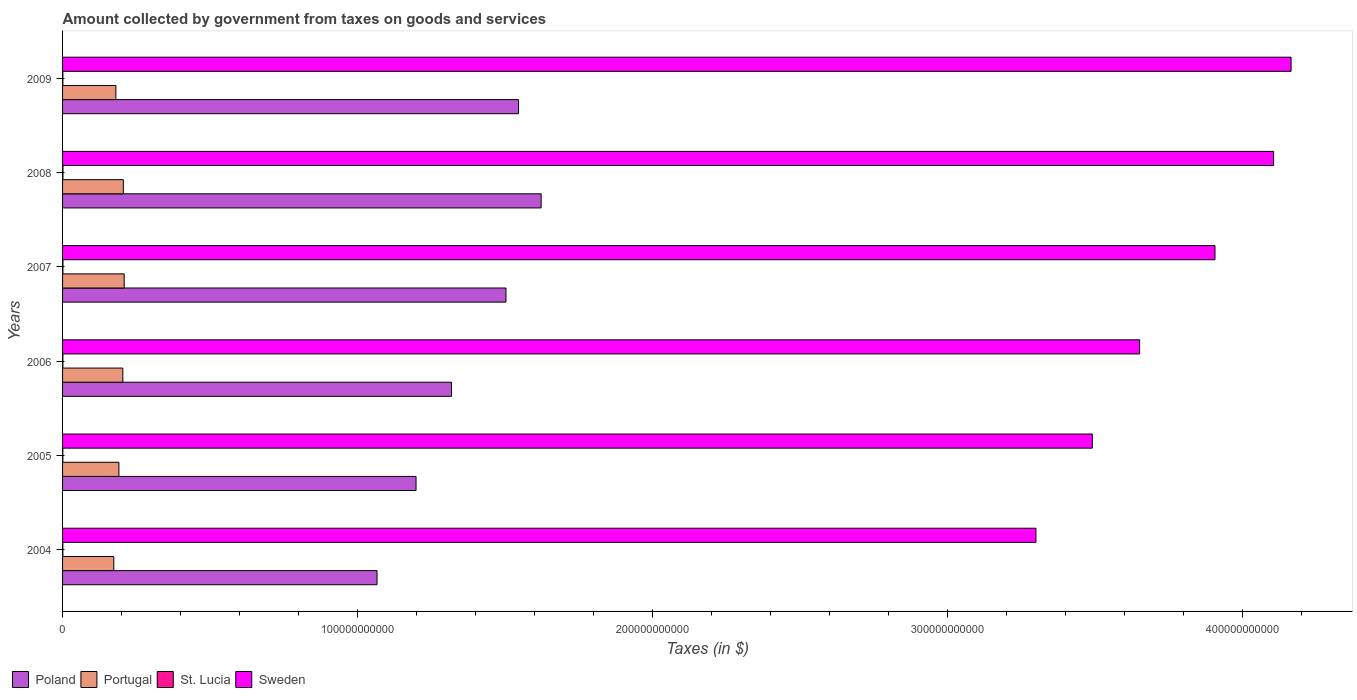How many groups of bars are there?
Make the answer very short. 6. Are the number of bars per tick equal to the number of legend labels?
Provide a succinct answer. Yes. What is the amount collected by government from taxes on goods and services in Portugal in 2006?
Offer a terse response. 2.04e+1. Across all years, what is the maximum amount collected by government from taxes on goods and services in Poland?
Provide a short and direct response. 1.62e+11. Across all years, what is the minimum amount collected by government from taxes on goods and services in Poland?
Your answer should be very brief. 1.07e+11. In which year was the amount collected by government from taxes on goods and services in Portugal maximum?
Give a very brief answer. 2007. What is the total amount collected by government from taxes on goods and services in St. Lucia in the graph?
Give a very brief answer. 6.48e+08. What is the difference between the amount collected by government from taxes on goods and services in St. Lucia in 2006 and that in 2008?
Keep it short and to the point. -2.66e+07. What is the difference between the amount collected by government from taxes on goods and services in Poland in 2004 and the amount collected by government from taxes on goods and services in Portugal in 2005?
Provide a short and direct response. 8.75e+1. What is the average amount collected by government from taxes on goods and services in St. Lucia per year?
Ensure brevity in your answer.  1.08e+08. In the year 2006, what is the difference between the amount collected by government from taxes on goods and services in Portugal and amount collected by government from taxes on goods and services in St. Lucia?
Your answer should be very brief. 2.03e+1. In how many years, is the amount collected by government from taxes on goods and services in St. Lucia greater than 260000000000 $?
Offer a very short reply. 0. What is the ratio of the amount collected by government from taxes on goods and services in Poland in 2005 to that in 2009?
Your response must be concise. 0.78. Is the amount collected by government from taxes on goods and services in St. Lucia in 2008 less than that in 2009?
Give a very brief answer. No. Is the difference between the amount collected by government from taxes on goods and services in Portugal in 2004 and 2005 greater than the difference between the amount collected by government from taxes on goods and services in St. Lucia in 2004 and 2005?
Your answer should be very brief. No. What is the difference between the highest and the second highest amount collected by government from taxes on goods and services in Sweden?
Make the answer very short. 5.91e+09. What is the difference between the highest and the lowest amount collected by government from taxes on goods and services in St. Lucia?
Your answer should be very brief. 4.27e+07. In how many years, is the amount collected by government from taxes on goods and services in St. Lucia greater than the average amount collected by government from taxes on goods and services in St. Lucia taken over all years?
Make the answer very short. 2. Is the sum of the amount collected by government from taxes on goods and services in St. Lucia in 2007 and 2008 greater than the maximum amount collected by government from taxes on goods and services in Portugal across all years?
Your answer should be very brief. No. Is it the case that in every year, the sum of the amount collected by government from taxes on goods and services in Sweden and amount collected by government from taxes on goods and services in Poland is greater than the sum of amount collected by government from taxes on goods and services in St. Lucia and amount collected by government from taxes on goods and services in Portugal?
Ensure brevity in your answer.  Yes. What is the difference between two consecutive major ticks on the X-axis?
Provide a short and direct response. 1.00e+11. Does the graph contain any zero values?
Make the answer very short. No. Where does the legend appear in the graph?
Your response must be concise. Bottom left. How are the legend labels stacked?
Ensure brevity in your answer.  Horizontal. What is the title of the graph?
Make the answer very short. Amount collected by government from taxes on goods and services. What is the label or title of the X-axis?
Offer a terse response. Taxes (in $). What is the label or title of the Y-axis?
Make the answer very short. Years. What is the Taxes (in $) of Poland in 2004?
Make the answer very short. 1.07e+11. What is the Taxes (in $) of Portugal in 2004?
Your answer should be compact. 1.74e+1. What is the Taxes (in $) of St. Lucia in 2004?
Make the answer very short. 9.33e+07. What is the Taxes (in $) in Sweden in 2004?
Make the answer very short. 3.30e+11. What is the Taxes (in $) in Poland in 2005?
Your answer should be very brief. 1.20e+11. What is the Taxes (in $) in Portugal in 2005?
Your answer should be very brief. 1.91e+1. What is the Taxes (in $) of St. Lucia in 2005?
Offer a terse response. 8.95e+07. What is the Taxes (in $) in Sweden in 2005?
Give a very brief answer. 3.49e+11. What is the Taxes (in $) of Poland in 2006?
Ensure brevity in your answer.  1.32e+11. What is the Taxes (in $) in Portugal in 2006?
Your response must be concise. 2.04e+1. What is the Taxes (in $) of St. Lucia in 2006?
Your answer should be very brief. 1.06e+08. What is the Taxes (in $) of Sweden in 2006?
Give a very brief answer. 3.65e+11. What is the Taxes (in $) of Poland in 2007?
Offer a terse response. 1.50e+11. What is the Taxes (in $) of Portugal in 2007?
Provide a short and direct response. 2.09e+1. What is the Taxes (in $) of St. Lucia in 2007?
Keep it short and to the point. 1.20e+08. What is the Taxes (in $) in Sweden in 2007?
Your response must be concise. 3.91e+11. What is the Taxes (in $) in Poland in 2008?
Provide a succinct answer. 1.62e+11. What is the Taxes (in $) of Portugal in 2008?
Your answer should be very brief. 2.06e+1. What is the Taxes (in $) of St. Lucia in 2008?
Make the answer very short. 1.32e+08. What is the Taxes (in $) in Sweden in 2008?
Ensure brevity in your answer.  4.10e+11. What is the Taxes (in $) in Poland in 2009?
Offer a very short reply. 1.55e+11. What is the Taxes (in $) of Portugal in 2009?
Offer a very short reply. 1.81e+1. What is the Taxes (in $) in St. Lucia in 2009?
Your answer should be very brief. 1.07e+08. What is the Taxes (in $) in Sweden in 2009?
Ensure brevity in your answer.  4.16e+11. Across all years, what is the maximum Taxes (in $) in Poland?
Give a very brief answer. 1.62e+11. Across all years, what is the maximum Taxes (in $) of Portugal?
Give a very brief answer. 2.09e+1. Across all years, what is the maximum Taxes (in $) in St. Lucia?
Provide a succinct answer. 1.32e+08. Across all years, what is the maximum Taxes (in $) of Sweden?
Make the answer very short. 4.16e+11. Across all years, what is the minimum Taxes (in $) of Poland?
Make the answer very short. 1.07e+11. Across all years, what is the minimum Taxes (in $) of Portugal?
Provide a short and direct response. 1.74e+1. Across all years, what is the minimum Taxes (in $) of St. Lucia?
Keep it short and to the point. 8.95e+07. Across all years, what is the minimum Taxes (in $) of Sweden?
Keep it short and to the point. 3.30e+11. What is the total Taxes (in $) in Poland in the graph?
Your answer should be very brief. 8.25e+11. What is the total Taxes (in $) of Portugal in the graph?
Ensure brevity in your answer.  1.16e+11. What is the total Taxes (in $) of St. Lucia in the graph?
Keep it short and to the point. 6.48e+08. What is the total Taxes (in $) of Sweden in the graph?
Offer a very short reply. 2.26e+12. What is the difference between the Taxes (in $) in Poland in 2004 and that in 2005?
Offer a very short reply. -1.32e+1. What is the difference between the Taxes (in $) in Portugal in 2004 and that in 2005?
Keep it short and to the point. -1.73e+09. What is the difference between the Taxes (in $) in St. Lucia in 2004 and that in 2005?
Your answer should be very brief. 3.80e+06. What is the difference between the Taxes (in $) of Sweden in 2004 and that in 2005?
Give a very brief answer. -1.91e+1. What is the difference between the Taxes (in $) of Poland in 2004 and that in 2006?
Give a very brief answer. -2.52e+1. What is the difference between the Taxes (in $) in Portugal in 2004 and that in 2006?
Your response must be concise. -3.06e+09. What is the difference between the Taxes (in $) in St. Lucia in 2004 and that in 2006?
Your answer should be compact. -1.23e+07. What is the difference between the Taxes (in $) in Sweden in 2004 and that in 2006?
Ensure brevity in your answer.  -3.51e+1. What is the difference between the Taxes (in $) in Poland in 2004 and that in 2007?
Give a very brief answer. -4.37e+1. What is the difference between the Taxes (in $) in Portugal in 2004 and that in 2007?
Ensure brevity in your answer.  -3.52e+09. What is the difference between the Taxes (in $) of St. Lucia in 2004 and that in 2007?
Give a very brief answer. -2.64e+07. What is the difference between the Taxes (in $) in Sweden in 2004 and that in 2007?
Keep it short and to the point. -6.07e+1. What is the difference between the Taxes (in $) of Poland in 2004 and that in 2008?
Make the answer very short. -5.56e+1. What is the difference between the Taxes (in $) of Portugal in 2004 and that in 2008?
Provide a short and direct response. -3.23e+09. What is the difference between the Taxes (in $) of St. Lucia in 2004 and that in 2008?
Your answer should be compact. -3.89e+07. What is the difference between the Taxes (in $) in Sweden in 2004 and that in 2008?
Make the answer very short. -8.06e+1. What is the difference between the Taxes (in $) in Poland in 2004 and that in 2009?
Your response must be concise. -4.80e+1. What is the difference between the Taxes (in $) of Portugal in 2004 and that in 2009?
Offer a terse response. -7.10e+08. What is the difference between the Taxes (in $) in St. Lucia in 2004 and that in 2009?
Make the answer very short. -1.41e+07. What is the difference between the Taxes (in $) of Sweden in 2004 and that in 2009?
Give a very brief answer. -8.65e+1. What is the difference between the Taxes (in $) in Poland in 2005 and that in 2006?
Your answer should be compact. -1.20e+1. What is the difference between the Taxes (in $) in Portugal in 2005 and that in 2006?
Give a very brief answer. -1.32e+09. What is the difference between the Taxes (in $) in St. Lucia in 2005 and that in 2006?
Provide a short and direct response. -1.61e+07. What is the difference between the Taxes (in $) of Sweden in 2005 and that in 2006?
Provide a short and direct response. -1.60e+1. What is the difference between the Taxes (in $) in Poland in 2005 and that in 2007?
Offer a terse response. -3.05e+1. What is the difference between the Taxes (in $) of Portugal in 2005 and that in 2007?
Give a very brief answer. -1.78e+09. What is the difference between the Taxes (in $) in St. Lucia in 2005 and that in 2007?
Your answer should be compact. -3.02e+07. What is the difference between the Taxes (in $) in Sweden in 2005 and that in 2007?
Your response must be concise. -4.16e+1. What is the difference between the Taxes (in $) in Poland in 2005 and that in 2008?
Your answer should be very brief. -4.24e+1. What is the difference between the Taxes (in $) in Portugal in 2005 and that in 2008?
Make the answer very short. -1.50e+09. What is the difference between the Taxes (in $) in St. Lucia in 2005 and that in 2008?
Make the answer very short. -4.27e+07. What is the difference between the Taxes (in $) in Sweden in 2005 and that in 2008?
Provide a succinct answer. -6.15e+1. What is the difference between the Taxes (in $) in Poland in 2005 and that in 2009?
Give a very brief answer. -3.47e+1. What is the difference between the Taxes (in $) in Portugal in 2005 and that in 2009?
Give a very brief answer. 1.02e+09. What is the difference between the Taxes (in $) of St. Lucia in 2005 and that in 2009?
Your response must be concise. -1.79e+07. What is the difference between the Taxes (in $) of Sweden in 2005 and that in 2009?
Make the answer very short. -6.74e+1. What is the difference between the Taxes (in $) in Poland in 2006 and that in 2007?
Your answer should be compact. -1.85e+1. What is the difference between the Taxes (in $) of Portugal in 2006 and that in 2007?
Offer a terse response. -4.60e+08. What is the difference between the Taxes (in $) in St. Lucia in 2006 and that in 2007?
Give a very brief answer. -1.41e+07. What is the difference between the Taxes (in $) of Sweden in 2006 and that in 2007?
Ensure brevity in your answer.  -2.55e+1. What is the difference between the Taxes (in $) in Poland in 2006 and that in 2008?
Your response must be concise. -3.04e+1. What is the difference between the Taxes (in $) in Portugal in 2006 and that in 2008?
Your answer should be compact. -1.75e+08. What is the difference between the Taxes (in $) of St. Lucia in 2006 and that in 2008?
Ensure brevity in your answer.  -2.66e+07. What is the difference between the Taxes (in $) in Sweden in 2006 and that in 2008?
Give a very brief answer. -4.54e+1. What is the difference between the Taxes (in $) in Poland in 2006 and that in 2009?
Your answer should be compact. -2.27e+1. What is the difference between the Taxes (in $) of Portugal in 2006 and that in 2009?
Your answer should be very brief. 2.35e+09. What is the difference between the Taxes (in $) of St. Lucia in 2006 and that in 2009?
Offer a very short reply. -1.80e+06. What is the difference between the Taxes (in $) of Sweden in 2006 and that in 2009?
Ensure brevity in your answer.  -5.13e+1. What is the difference between the Taxes (in $) of Poland in 2007 and that in 2008?
Your answer should be very brief. -1.19e+1. What is the difference between the Taxes (in $) of Portugal in 2007 and that in 2008?
Provide a short and direct response. 2.85e+08. What is the difference between the Taxes (in $) of St. Lucia in 2007 and that in 2008?
Offer a very short reply. -1.25e+07. What is the difference between the Taxes (in $) in Sweden in 2007 and that in 2008?
Offer a terse response. -1.99e+1. What is the difference between the Taxes (in $) in Poland in 2007 and that in 2009?
Your answer should be very brief. -4.26e+09. What is the difference between the Taxes (in $) of Portugal in 2007 and that in 2009?
Your response must be concise. 2.81e+09. What is the difference between the Taxes (in $) in St. Lucia in 2007 and that in 2009?
Your answer should be very brief. 1.23e+07. What is the difference between the Taxes (in $) in Sweden in 2007 and that in 2009?
Offer a terse response. -2.58e+1. What is the difference between the Taxes (in $) in Poland in 2008 and that in 2009?
Provide a succinct answer. 7.66e+09. What is the difference between the Taxes (in $) of Portugal in 2008 and that in 2009?
Keep it short and to the point. 2.52e+09. What is the difference between the Taxes (in $) of St. Lucia in 2008 and that in 2009?
Your answer should be very brief. 2.48e+07. What is the difference between the Taxes (in $) in Sweden in 2008 and that in 2009?
Keep it short and to the point. -5.91e+09. What is the difference between the Taxes (in $) in Poland in 2004 and the Taxes (in $) in Portugal in 2005?
Provide a succinct answer. 8.75e+1. What is the difference between the Taxes (in $) of Poland in 2004 and the Taxes (in $) of St. Lucia in 2005?
Make the answer very short. 1.06e+11. What is the difference between the Taxes (in $) of Poland in 2004 and the Taxes (in $) of Sweden in 2005?
Keep it short and to the point. -2.42e+11. What is the difference between the Taxes (in $) in Portugal in 2004 and the Taxes (in $) in St. Lucia in 2005?
Provide a succinct answer. 1.73e+1. What is the difference between the Taxes (in $) in Portugal in 2004 and the Taxes (in $) in Sweden in 2005?
Provide a succinct answer. -3.32e+11. What is the difference between the Taxes (in $) of St. Lucia in 2004 and the Taxes (in $) of Sweden in 2005?
Ensure brevity in your answer.  -3.49e+11. What is the difference between the Taxes (in $) in Poland in 2004 and the Taxes (in $) in Portugal in 2006?
Your answer should be compact. 8.62e+1. What is the difference between the Taxes (in $) of Poland in 2004 and the Taxes (in $) of St. Lucia in 2006?
Ensure brevity in your answer.  1.06e+11. What is the difference between the Taxes (in $) of Poland in 2004 and the Taxes (in $) of Sweden in 2006?
Keep it short and to the point. -2.58e+11. What is the difference between the Taxes (in $) of Portugal in 2004 and the Taxes (in $) of St. Lucia in 2006?
Offer a very short reply. 1.73e+1. What is the difference between the Taxes (in $) in Portugal in 2004 and the Taxes (in $) in Sweden in 2006?
Offer a terse response. -3.48e+11. What is the difference between the Taxes (in $) of St. Lucia in 2004 and the Taxes (in $) of Sweden in 2006?
Ensure brevity in your answer.  -3.65e+11. What is the difference between the Taxes (in $) of Poland in 2004 and the Taxes (in $) of Portugal in 2007?
Provide a short and direct response. 8.57e+1. What is the difference between the Taxes (in $) of Poland in 2004 and the Taxes (in $) of St. Lucia in 2007?
Ensure brevity in your answer.  1.06e+11. What is the difference between the Taxes (in $) in Poland in 2004 and the Taxes (in $) in Sweden in 2007?
Offer a terse response. -2.84e+11. What is the difference between the Taxes (in $) in Portugal in 2004 and the Taxes (in $) in St. Lucia in 2007?
Provide a succinct answer. 1.72e+1. What is the difference between the Taxes (in $) of Portugal in 2004 and the Taxes (in $) of Sweden in 2007?
Give a very brief answer. -3.73e+11. What is the difference between the Taxes (in $) in St. Lucia in 2004 and the Taxes (in $) in Sweden in 2007?
Make the answer very short. -3.91e+11. What is the difference between the Taxes (in $) in Poland in 2004 and the Taxes (in $) in Portugal in 2008?
Your response must be concise. 8.60e+1. What is the difference between the Taxes (in $) of Poland in 2004 and the Taxes (in $) of St. Lucia in 2008?
Keep it short and to the point. 1.06e+11. What is the difference between the Taxes (in $) in Poland in 2004 and the Taxes (in $) in Sweden in 2008?
Offer a terse response. -3.04e+11. What is the difference between the Taxes (in $) of Portugal in 2004 and the Taxes (in $) of St. Lucia in 2008?
Provide a succinct answer. 1.72e+1. What is the difference between the Taxes (in $) in Portugal in 2004 and the Taxes (in $) in Sweden in 2008?
Your response must be concise. -3.93e+11. What is the difference between the Taxes (in $) in St. Lucia in 2004 and the Taxes (in $) in Sweden in 2008?
Your response must be concise. -4.10e+11. What is the difference between the Taxes (in $) in Poland in 2004 and the Taxes (in $) in Portugal in 2009?
Provide a succinct answer. 8.85e+1. What is the difference between the Taxes (in $) in Poland in 2004 and the Taxes (in $) in St. Lucia in 2009?
Offer a terse response. 1.06e+11. What is the difference between the Taxes (in $) in Poland in 2004 and the Taxes (in $) in Sweden in 2009?
Provide a succinct answer. -3.10e+11. What is the difference between the Taxes (in $) in Portugal in 2004 and the Taxes (in $) in St. Lucia in 2009?
Provide a succinct answer. 1.73e+1. What is the difference between the Taxes (in $) of Portugal in 2004 and the Taxes (in $) of Sweden in 2009?
Ensure brevity in your answer.  -3.99e+11. What is the difference between the Taxes (in $) of St. Lucia in 2004 and the Taxes (in $) of Sweden in 2009?
Your answer should be compact. -4.16e+11. What is the difference between the Taxes (in $) in Poland in 2005 and the Taxes (in $) in Portugal in 2006?
Ensure brevity in your answer.  9.94e+1. What is the difference between the Taxes (in $) in Poland in 2005 and the Taxes (in $) in St. Lucia in 2006?
Your answer should be very brief. 1.20e+11. What is the difference between the Taxes (in $) of Poland in 2005 and the Taxes (in $) of Sweden in 2006?
Your response must be concise. -2.45e+11. What is the difference between the Taxes (in $) in Portugal in 2005 and the Taxes (in $) in St. Lucia in 2006?
Make the answer very short. 1.90e+1. What is the difference between the Taxes (in $) of Portugal in 2005 and the Taxes (in $) of Sweden in 2006?
Your answer should be very brief. -3.46e+11. What is the difference between the Taxes (in $) of St. Lucia in 2005 and the Taxes (in $) of Sweden in 2006?
Keep it short and to the point. -3.65e+11. What is the difference between the Taxes (in $) of Poland in 2005 and the Taxes (in $) of Portugal in 2007?
Keep it short and to the point. 9.89e+1. What is the difference between the Taxes (in $) of Poland in 2005 and the Taxes (in $) of St. Lucia in 2007?
Provide a succinct answer. 1.20e+11. What is the difference between the Taxes (in $) in Poland in 2005 and the Taxes (in $) in Sweden in 2007?
Ensure brevity in your answer.  -2.71e+11. What is the difference between the Taxes (in $) of Portugal in 2005 and the Taxes (in $) of St. Lucia in 2007?
Offer a terse response. 1.90e+1. What is the difference between the Taxes (in $) in Portugal in 2005 and the Taxes (in $) in Sweden in 2007?
Make the answer very short. -3.72e+11. What is the difference between the Taxes (in $) in St. Lucia in 2005 and the Taxes (in $) in Sweden in 2007?
Your response must be concise. -3.91e+11. What is the difference between the Taxes (in $) of Poland in 2005 and the Taxes (in $) of Portugal in 2008?
Give a very brief answer. 9.92e+1. What is the difference between the Taxes (in $) of Poland in 2005 and the Taxes (in $) of St. Lucia in 2008?
Give a very brief answer. 1.20e+11. What is the difference between the Taxes (in $) of Poland in 2005 and the Taxes (in $) of Sweden in 2008?
Make the answer very short. -2.91e+11. What is the difference between the Taxes (in $) in Portugal in 2005 and the Taxes (in $) in St. Lucia in 2008?
Offer a terse response. 1.90e+1. What is the difference between the Taxes (in $) in Portugal in 2005 and the Taxes (in $) in Sweden in 2008?
Provide a short and direct response. -3.91e+11. What is the difference between the Taxes (in $) in St. Lucia in 2005 and the Taxes (in $) in Sweden in 2008?
Keep it short and to the point. -4.10e+11. What is the difference between the Taxes (in $) in Poland in 2005 and the Taxes (in $) in Portugal in 2009?
Give a very brief answer. 1.02e+11. What is the difference between the Taxes (in $) in Poland in 2005 and the Taxes (in $) in St. Lucia in 2009?
Your answer should be compact. 1.20e+11. What is the difference between the Taxes (in $) of Poland in 2005 and the Taxes (in $) of Sweden in 2009?
Give a very brief answer. -2.97e+11. What is the difference between the Taxes (in $) in Portugal in 2005 and the Taxes (in $) in St. Lucia in 2009?
Ensure brevity in your answer.  1.90e+1. What is the difference between the Taxes (in $) of Portugal in 2005 and the Taxes (in $) of Sweden in 2009?
Offer a very short reply. -3.97e+11. What is the difference between the Taxes (in $) of St. Lucia in 2005 and the Taxes (in $) of Sweden in 2009?
Your answer should be very brief. -4.16e+11. What is the difference between the Taxes (in $) of Poland in 2006 and the Taxes (in $) of Portugal in 2007?
Provide a succinct answer. 1.11e+11. What is the difference between the Taxes (in $) in Poland in 2006 and the Taxes (in $) in St. Lucia in 2007?
Make the answer very short. 1.32e+11. What is the difference between the Taxes (in $) in Poland in 2006 and the Taxes (in $) in Sweden in 2007?
Give a very brief answer. -2.59e+11. What is the difference between the Taxes (in $) of Portugal in 2006 and the Taxes (in $) of St. Lucia in 2007?
Your answer should be very brief. 2.03e+1. What is the difference between the Taxes (in $) of Portugal in 2006 and the Taxes (in $) of Sweden in 2007?
Provide a succinct answer. -3.70e+11. What is the difference between the Taxes (in $) of St. Lucia in 2006 and the Taxes (in $) of Sweden in 2007?
Make the answer very short. -3.91e+11. What is the difference between the Taxes (in $) of Poland in 2006 and the Taxes (in $) of Portugal in 2008?
Provide a succinct answer. 1.11e+11. What is the difference between the Taxes (in $) in Poland in 2006 and the Taxes (in $) in St. Lucia in 2008?
Offer a terse response. 1.32e+11. What is the difference between the Taxes (in $) in Poland in 2006 and the Taxes (in $) in Sweden in 2008?
Make the answer very short. -2.79e+11. What is the difference between the Taxes (in $) of Portugal in 2006 and the Taxes (in $) of St. Lucia in 2008?
Make the answer very short. 2.03e+1. What is the difference between the Taxes (in $) of Portugal in 2006 and the Taxes (in $) of Sweden in 2008?
Your response must be concise. -3.90e+11. What is the difference between the Taxes (in $) in St. Lucia in 2006 and the Taxes (in $) in Sweden in 2008?
Your response must be concise. -4.10e+11. What is the difference between the Taxes (in $) of Poland in 2006 and the Taxes (in $) of Portugal in 2009?
Your response must be concise. 1.14e+11. What is the difference between the Taxes (in $) of Poland in 2006 and the Taxes (in $) of St. Lucia in 2009?
Keep it short and to the point. 1.32e+11. What is the difference between the Taxes (in $) in Poland in 2006 and the Taxes (in $) in Sweden in 2009?
Your answer should be compact. -2.85e+11. What is the difference between the Taxes (in $) in Portugal in 2006 and the Taxes (in $) in St. Lucia in 2009?
Provide a succinct answer. 2.03e+1. What is the difference between the Taxes (in $) of Portugal in 2006 and the Taxes (in $) of Sweden in 2009?
Make the answer very short. -3.96e+11. What is the difference between the Taxes (in $) in St. Lucia in 2006 and the Taxes (in $) in Sweden in 2009?
Offer a very short reply. -4.16e+11. What is the difference between the Taxes (in $) in Poland in 2007 and the Taxes (in $) in Portugal in 2008?
Your answer should be very brief. 1.30e+11. What is the difference between the Taxes (in $) in Poland in 2007 and the Taxes (in $) in St. Lucia in 2008?
Give a very brief answer. 1.50e+11. What is the difference between the Taxes (in $) of Poland in 2007 and the Taxes (in $) of Sweden in 2008?
Your response must be concise. -2.60e+11. What is the difference between the Taxes (in $) of Portugal in 2007 and the Taxes (in $) of St. Lucia in 2008?
Keep it short and to the point. 2.07e+1. What is the difference between the Taxes (in $) in Portugal in 2007 and the Taxes (in $) in Sweden in 2008?
Offer a very short reply. -3.90e+11. What is the difference between the Taxes (in $) in St. Lucia in 2007 and the Taxes (in $) in Sweden in 2008?
Give a very brief answer. -4.10e+11. What is the difference between the Taxes (in $) in Poland in 2007 and the Taxes (in $) in Portugal in 2009?
Your answer should be very brief. 1.32e+11. What is the difference between the Taxes (in $) of Poland in 2007 and the Taxes (in $) of St. Lucia in 2009?
Provide a succinct answer. 1.50e+11. What is the difference between the Taxes (in $) of Poland in 2007 and the Taxes (in $) of Sweden in 2009?
Provide a succinct answer. -2.66e+11. What is the difference between the Taxes (in $) of Portugal in 2007 and the Taxes (in $) of St. Lucia in 2009?
Offer a terse response. 2.08e+1. What is the difference between the Taxes (in $) in Portugal in 2007 and the Taxes (in $) in Sweden in 2009?
Give a very brief answer. -3.96e+11. What is the difference between the Taxes (in $) of St. Lucia in 2007 and the Taxes (in $) of Sweden in 2009?
Your response must be concise. -4.16e+11. What is the difference between the Taxes (in $) in Poland in 2008 and the Taxes (in $) in Portugal in 2009?
Offer a terse response. 1.44e+11. What is the difference between the Taxes (in $) of Poland in 2008 and the Taxes (in $) of St. Lucia in 2009?
Give a very brief answer. 1.62e+11. What is the difference between the Taxes (in $) in Poland in 2008 and the Taxes (in $) in Sweden in 2009?
Your answer should be compact. -2.54e+11. What is the difference between the Taxes (in $) in Portugal in 2008 and the Taxes (in $) in St. Lucia in 2009?
Your response must be concise. 2.05e+1. What is the difference between the Taxes (in $) in Portugal in 2008 and the Taxes (in $) in Sweden in 2009?
Ensure brevity in your answer.  -3.96e+11. What is the difference between the Taxes (in $) in St. Lucia in 2008 and the Taxes (in $) in Sweden in 2009?
Offer a terse response. -4.16e+11. What is the average Taxes (in $) in Poland per year?
Offer a very short reply. 1.38e+11. What is the average Taxes (in $) in Portugal per year?
Provide a short and direct response. 1.94e+1. What is the average Taxes (in $) of St. Lucia per year?
Your response must be concise. 1.08e+08. What is the average Taxes (in $) of Sweden per year?
Provide a succinct answer. 3.77e+11. In the year 2004, what is the difference between the Taxes (in $) of Poland and Taxes (in $) of Portugal?
Your response must be concise. 8.92e+1. In the year 2004, what is the difference between the Taxes (in $) in Poland and Taxes (in $) in St. Lucia?
Provide a short and direct response. 1.06e+11. In the year 2004, what is the difference between the Taxes (in $) in Poland and Taxes (in $) in Sweden?
Offer a very short reply. -2.23e+11. In the year 2004, what is the difference between the Taxes (in $) of Portugal and Taxes (in $) of St. Lucia?
Your response must be concise. 1.73e+1. In the year 2004, what is the difference between the Taxes (in $) in Portugal and Taxes (in $) in Sweden?
Offer a very short reply. -3.13e+11. In the year 2004, what is the difference between the Taxes (in $) in St. Lucia and Taxes (in $) in Sweden?
Give a very brief answer. -3.30e+11. In the year 2005, what is the difference between the Taxes (in $) of Poland and Taxes (in $) of Portugal?
Offer a terse response. 1.01e+11. In the year 2005, what is the difference between the Taxes (in $) in Poland and Taxes (in $) in St. Lucia?
Your response must be concise. 1.20e+11. In the year 2005, what is the difference between the Taxes (in $) in Poland and Taxes (in $) in Sweden?
Provide a short and direct response. -2.29e+11. In the year 2005, what is the difference between the Taxes (in $) in Portugal and Taxes (in $) in St. Lucia?
Offer a terse response. 1.90e+1. In the year 2005, what is the difference between the Taxes (in $) in Portugal and Taxes (in $) in Sweden?
Provide a short and direct response. -3.30e+11. In the year 2005, what is the difference between the Taxes (in $) in St. Lucia and Taxes (in $) in Sweden?
Ensure brevity in your answer.  -3.49e+11. In the year 2006, what is the difference between the Taxes (in $) in Poland and Taxes (in $) in Portugal?
Make the answer very short. 1.11e+11. In the year 2006, what is the difference between the Taxes (in $) of Poland and Taxes (in $) of St. Lucia?
Make the answer very short. 1.32e+11. In the year 2006, what is the difference between the Taxes (in $) in Poland and Taxes (in $) in Sweden?
Ensure brevity in your answer.  -2.33e+11. In the year 2006, what is the difference between the Taxes (in $) of Portugal and Taxes (in $) of St. Lucia?
Provide a succinct answer. 2.03e+1. In the year 2006, what is the difference between the Taxes (in $) in Portugal and Taxes (in $) in Sweden?
Keep it short and to the point. -3.45e+11. In the year 2006, what is the difference between the Taxes (in $) of St. Lucia and Taxes (in $) of Sweden?
Your answer should be compact. -3.65e+11. In the year 2007, what is the difference between the Taxes (in $) of Poland and Taxes (in $) of Portugal?
Your response must be concise. 1.29e+11. In the year 2007, what is the difference between the Taxes (in $) of Poland and Taxes (in $) of St. Lucia?
Ensure brevity in your answer.  1.50e+11. In the year 2007, what is the difference between the Taxes (in $) of Poland and Taxes (in $) of Sweden?
Offer a very short reply. -2.40e+11. In the year 2007, what is the difference between the Taxes (in $) of Portugal and Taxes (in $) of St. Lucia?
Your answer should be compact. 2.08e+1. In the year 2007, what is the difference between the Taxes (in $) of Portugal and Taxes (in $) of Sweden?
Offer a terse response. -3.70e+11. In the year 2007, what is the difference between the Taxes (in $) of St. Lucia and Taxes (in $) of Sweden?
Give a very brief answer. -3.90e+11. In the year 2008, what is the difference between the Taxes (in $) of Poland and Taxes (in $) of Portugal?
Your response must be concise. 1.42e+11. In the year 2008, what is the difference between the Taxes (in $) in Poland and Taxes (in $) in St. Lucia?
Your answer should be very brief. 1.62e+11. In the year 2008, what is the difference between the Taxes (in $) in Poland and Taxes (in $) in Sweden?
Provide a succinct answer. -2.48e+11. In the year 2008, what is the difference between the Taxes (in $) of Portugal and Taxes (in $) of St. Lucia?
Keep it short and to the point. 2.05e+1. In the year 2008, what is the difference between the Taxes (in $) of Portugal and Taxes (in $) of Sweden?
Provide a short and direct response. -3.90e+11. In the year 2008, what is the difference between the Taxes (in $) in St. Lucia and Taxes (in $) in Sweden?
Provide a succinct answer. -4.10e+11. In the year 2009, what is the difference between the Taxes (in $) in Poland and Taxes (in $) in Portugal?
Offer a very short reply. 1.36e+11. In the year 2009, what is the difference between the Taxes (in $) of Poland and Taxes (in $) of St. Lucia?
Keep it short and to the point. 1.54e+11. In the year 2009, what is the difference between the Taxes (in $) of Poland and Taxes (in $) of Sweden?
Offer a terse response. -2.62e+11. In the year 2009, what is the difference between the Taxes (in $) of Portugal and Taxes (in $) of St. Lucia?
Give a very brief answer. 1.80e+1. In the year 2009, what is the difference between the Taxes (in $) in Portugal and Taxes (in $) in Sweden?
Provide a succinct answer. -3.98e+11. In the year 2009, what is the difference between the Taxes (in $) in St. Lucia and Taxes (in $) in Sweden?
Provide a short and direct response. -4.16e+11. What is the ratio of the Taxes (in $) in Poland in 2004 to that in 2005?
Your answer should be very brief. 0.89. What is the ratio of the Taxes (in $) in Portugal in 2004 to that in 2005?
Provide a succinct answer. 0.91. What is the ratio of the Taxes (in $) in St. Lucia in 2004 to that in 2005?
Make the answer very short. 1.04. What is the ratio of the Taxes (in $) of Sweden in 2004 to that in 2005?
Ensure brevity in your answer.  0.95. What is the ratio of the Taxes (in $) in Poland in 2004 to that in 2006?
Provide a short and direct response. 0.81. What is the ratio of the Taxes (in $) in Portugal in 2004 to that in 2006?
Make the answer very short. 0.85. What is the ratio of the Taxes (in $) in St. Lucia in 2004 to that in 2006?
Your response must be concise. 0.88. What is the ratio of the Taxes (in $) of Sweden in 2004 to that in 2006?
Offer a terse response. 0.9. What is the ratio of the Taxes (in $) in Poland in 2004 to that in 2007?
Give a very brief answer. 0.71. What is the ratio of the Taxes (in $) in Portugal in 2004 to that in 2007?
Give a very brief answer. 0.83. What is the ratio of the Taxes (in $) in St. Lucia in 2004 to that in 2007?
Offer a very short reply. 0.78. What is the ratio of the Taxes (in $) in Sweden in 2004 to that in 2007?
Keep it short and to the point. 0.84. What is the ratio of the Taxes (in $) of Poland in 2004 to that in 2008?
Keep it short and to the point. 0.66. What is the ratio of the Taxes (in $) in Portugal in 2004 to that in 2008?
Give a very brief answer. 0.84. What is the ratio of the Taxes (in $) in St. Lucia in 2004 to that in 2008?
Give a very brief answer. 0.71. What is the ratio of the Taxes (in $) of Sweden in 2004 to that in 2008?
Keep it short and to the point. 0.8. What is the ratio of the Taxes (in $) in Poland in 2004 to that in 2009?
Keep it short and to the point. 0.69. What is the ratio of the Taxes (in $) of Portugal in 2004 to that in 2009?
Ensure brevity in your answer.  0.96. What is the ratio of the Taxes (in $) in St. Lucia in 2004 to that in 2009?
Your answer should be compact. 0.87. What is the ratio of the Taxes (in $) in Sweden in 2004 to that in 2009?
Your response must be concise. 0.79. What is the ratio of the Taxes (in $) in Poland in 2005 to that in 2006?
Your answer should be very brief. 0.91. What is the ratio of the Taxes (in $) in Portugal in 2005 to that in 2006?
Your answer should be very brief. 0.94. What is the ratio of the Taxes (in $) in St. Lucia in 2005 to that in 2006?
Make the answer very short. 0.85. What is the ratio of the Taxes (in $) of Sweden in 2005 to that in 2006?
Offer a very short reply. 0.96. What is the ratio of the Taxes (in $) in Poland in 2005 to that in 2007?
Keep it short and to the point. 0.8. What is the ratio of the Taxes (in $) in Portugal in 2005 to that in 2007?
Your answer should be very brief. 0.91. What is the ratio of the Taxes (in $) in St. Lucia in 2005 to that in 2007?
Provide a short and direct response. 0.75. What is the ratio of the Taxes (in $) in Sweden in 2005 to that in 2007?
Your answer should be very brief. 0.89. What is the ratio of the Taxes (in $) in Poland in 2005 to that in 2008?
Provide a succinct answer. 0.74. What is the ratio of the Taxes (in $) in Portugal in 2005 to that in 2008?
Ensure brevity in your answer.  0.93. What is the ratio of the Taxes (in $) in St. Lucia in 2005 to that in 2008?
Make the answer very short. 0.68. What is the ratio of the Taxes (in $) in Sweden in 2005 to that in 2008?
Ensure brevity in your answer.  0.85. What is the ratio of the Taxes (in $) of Poland in 2005 to that in 2009?
Offer a very short reply. 0.78. What is the ratio of the Taxes (in $) of Portugal in 2005 to that in 2009?
Your answer should be compact. 1.06. What is the ratio of the Taxes (in $) of St. Lucia in 2005 to that in 2009?
Provide a short and direct response. 0.83. What is the ratio of the Taxes (in $) in Sweden in 2005 to that in 2009?
Your answer should be very brief. 0.84. What is the ratio of the Taxes (in $) of Poland in 2006 to that in 2007?
Your answer should be compact. 0.88. What is the ratio of the Taxes (in $) of St. Lucia in 2006 to that in 2007?
Your answer should be very brief. 0.88. What is the ratio of the Taxes (in $) in Sweden in 2006 to that in 2007?
Provide a short and direct response. 0.93. What is the ratio of the Taxes (in $) of Poland in 2006 to that in 2008?
Ensure brevity in your answer.  0.81. What is the ratio of the Taxes (in $) of St. Lucia in 2006 to that in 2008?
Offer a terse response. 0.8. What is the ratio of the Taxes (in $) in Sweden in 2006 to that in 2008?
Your answer should be compact. 0.89. What is the ratio of the Taxes (in $) in Poland in 2006 to that in 2009?
Offer a terse response. 0.85. What is the ratio of the Taxes (in $) in Portugal in 2006 to that in 2009?
Make the answer very short. 1.13. What is the ratio of the Taxes (in $) of St. Lucia in 2006 to that in 2009?
Ensure brevity in your answer.  0.98. What is the ratio of the Taxes (in $) of Sweden in 2006 to that in 2009?
Keep it short and to the point. 0.88. What is the ratio of the Taxes (in $) of Poland in 2007 to that in 2008?
Keep it short and to the point. 0.93. What is the ratio of the Taxes (in $) in Portugal in 2007 to that in 2008?
Your response must be concise. 1.01. What is the ratio of the Taxes (in $) in St. Lucia in 2007 to that in 2008?
Provide a succinct answer. 0.91. What is the ratio of the Taxes (in $) in Sweden in 2007 to that in 2008?
Offer a very short reply. 0.95. What is the ratio of the Taxes (in $) in Poland in 2007 to that in 2009?
Your answer should be very brief. 0.97. What is the ratio of the Taxes (in $) of Portugal in 2007 to that in 2009?
Your answer should be very brief. 1.16. What is the ratio of the Taxes (in $) in St. Lucia in 2007 to that in 2009?
Offer a very short reply. 1.11. What is the ratio of the Taxes (in $) in Sweden in 2007 to that in 2009?
Your answer should be compact. 0.94. What is the ratio of the Taxes (in $) of Poland in 2008 to that in 2009?
Make the answer very short. 1.05. What is the ratio of the Taxes (in $) of Portugal in 2008 to that in 2009?
Provide a short and direct response. 1.14. What is the ratio of the Taxes (in $) of St. Lucia in 2008 to that in 2009?
Your response must be concise. 1.23. What is the ratio of the Taxes (in $) in Sweden in 2008 to that in 2009?
Provide a succinct answer. 0.99. What is the difference between the highest and the second highest Taxes (in $) of Poland?
Your answer should be very brief. 7.66e+09. What is the difference between the highest and the second highest Taxes (in $) in Portugal?
Make the answer very short. 2.85e+08. What is the difference between the highest and the second highest Taxes (in $) of St. Lucia?
Your response must be concise. 1.25e+07. What is the difference between the highest and the second highest Taxes (in $) in Sweden?
Provide a succinct answer. 5.91e+09. What is the difference between the highest and the lowest Taxes (in $) of Poland?
Your answer should be very brief. 5.56e+1. What is the difference between the highest and the lowest Taxes (in $) in Portugal?
Ensure brevity in your answer.  3.52e+09. What is the difference between the highest and the lowest Taxes (in $) in St. Lucia?
Offer a very short reply. 4.27e+07. What is the difference between the highest and the lowest Taxes (in $) in Sweden?
Provide a short and direct response. 8.65e+1. 